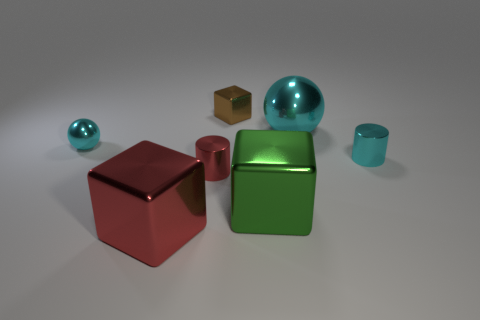What is the size of the object that is both behind the small cyan metal sphere and in front of the tiny shiny block?
Your answer should be compact. Large. What color is the big ball that is made of the same material as the large red thing?
Give a very brief answer. Cyan. There is a metallic cylinder that is in front of the small cyan metal cylinder; what is its size?
Provide a short and direct response. Small. Do the small block and the large cyan ball have the same material?
Make the answer very short. Yes. There is a cyan metallic thing that is on the left side of the sphere that is right of the brown thing; is there a big shiny sphere to the left of it?
Your response must be concise. No. What is the color of the small cube?
Offer a terse response. Brown. The ball that is the same size as the red metal cube is what color?
Your response must be concise. Cyan. Do the small thing to the right of the big green block and the green metallic object have the same shape?
Keep it short and to the point. No. There is a cylinder in front of the cyan metal object to the right of the sphere that is to the right of the big red metallic object; what is its color?
Provide a succinct answer. Red. Is there a small metallic thing?
Give a very brief answer. Yes. 